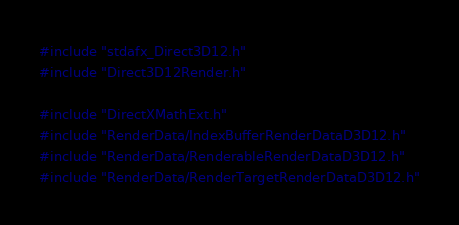<code> <loc_0><loc_0><loc_500><loc_500><_C++_>#include "stdafx_Direct3D12.h"
#include "Direct3D12Render.h"

#include "DirectXMathExt.h"
#include "RenderData/IndexBufferRenderDataD3D12.h"
#include "RenderData/RenderableRenderDataD3D12.h"
#include "RenderData/RenderTargetRenderDataD3D12.h"</code> 